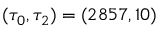Convert formula to latex. <formula><loc_0><loc_0><loc_500><loc_500>( \tau _ { 0 } , \tau _ { 2 } ) = ( 2 8 5 7 , 1 0 )</formula> 